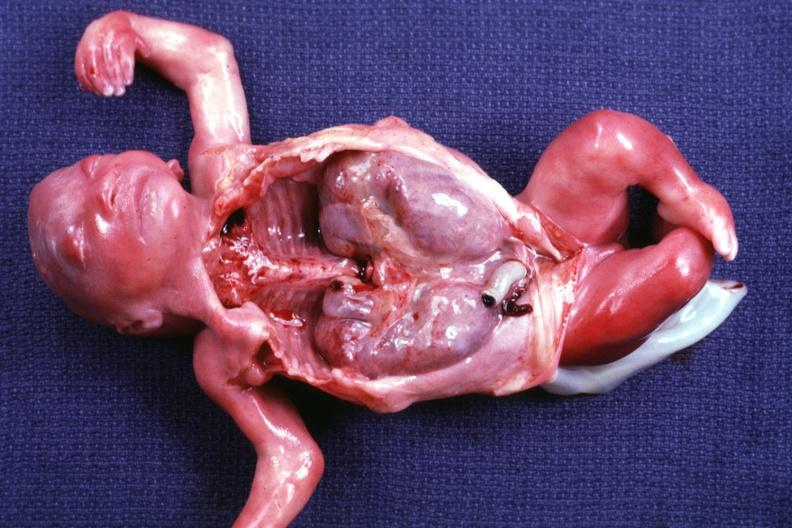what removed shows size of organs quite well and renal facies?
Answer the question using a single word or phrase. Opened dysmorphic body with all except kidneys 